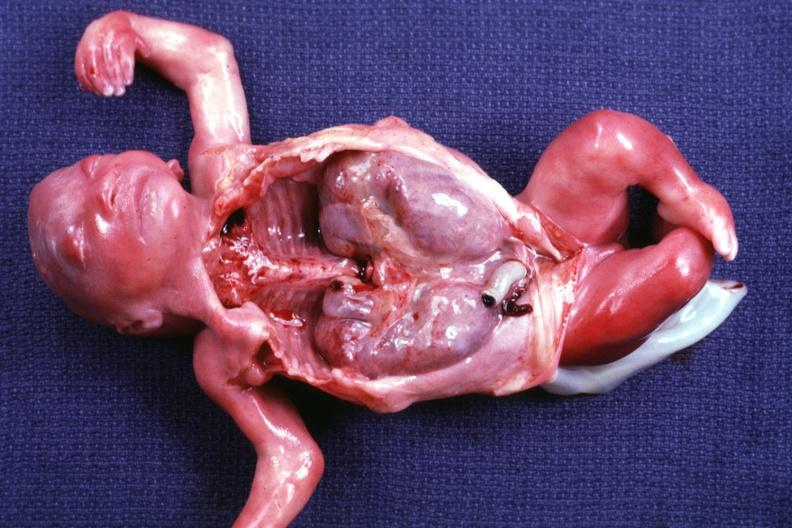what removed shows size of organs quite well and renal facies?
Answer the question using a single word or phrase. Opened dysmorphic body with all except kidneys 